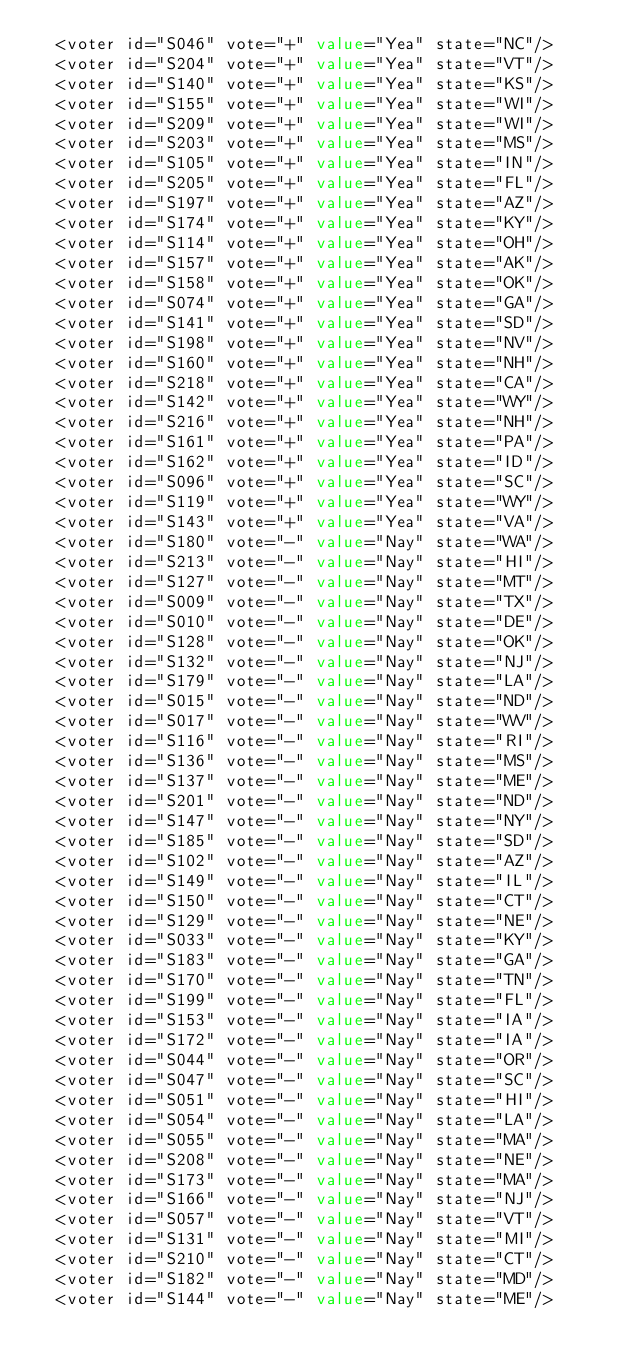<code> <loc_0><loc_0><loc_500><loc_500><_XML_>  <voter id="S046" vote="+" value="Yea" state="NC"/>
  <voter id="S204" vote="+" value="Yea" state="VT"/>
  <voter id="S140" vote="+" value="Yea" state="KS"/>
  <voter id="S155" vote="+" value="Yea" state="WI"/>
  <voter id="S209" vote="+" value="Yea" state="WI"/>
  <voter id="S203" vote="+" value="Yea" state="MS"/>
  <voter id="S105" vote="+" value="Yea" state="IN"/>
  <voter id="S205" vote="+" value="Yea" state="FL"/>
  <voter id="S197" vote="+" value="Yea" state="AZ"/>
  <voter id="S174" vote="+" value="Yea" state="KY"/>
  <voter id="S114" vote="+" value="Yea" state="OH"/>
  <voter id="S157" vote="+" value="Yea" state="AK"/>
  <voter id="S158" vote="+" value="Yea" state="OK"/>
  <voter id="S074" vote="+" value="Yea" state="GA"/>
  <voter id="S141" vote="+" value="Yea" state="SD"/>
  <voter id="S198" vote="+" value="Yea" state="NV"/>
  <voter id="S160" vote="+" value="Yea" state="NH"/>
  <voter id="S218" vote="+" value="Yea" state="CA"/>
  <voter id="S142" vote="+" value="Yea" state="WY"/>
  <voter id="S216" vote="+" value="Yea" state="NH"/>
  <voter id="S161" vote="+" value="Yea" state="PA"/>
  <voter id="S162" vote="+" value="Yea" state="ID"/>
  <voter id="S096" vote="+" value="Yea" state="SC"/>
  <voter id="S119" vote="+" value="Yea" state="WY"/>
  <voter id="S143" vote="+" value="Yea" state="VA"/>
  <voter id="S180" vote="-" value="Nay" state="WA"/>
  <voter id="S213" vote="-" value="Nay" state="HI"/>
  <voter id="S127" vote="-" value="Nay" state="MT"/>
  <voter id="S009" vote="-" value="Nay" state="TX"/>
  <voter id="S010" vote="-" value="Nay" state="DE"/>
  <voter id="S128" vote="-" value="Nay" state="OK"/>
  <voter id="S132" vote="-" value="Nay" state="NJ"/>
  <voter id="S179" vote="-" value="Nay" state="LA"/>
  <voter id="S015" vote="-" value="Nay" state="ND"/>
  <voter id="S017" vote="-" value="Nay" state="WV"/>
  <voter id="S116" vote="-" value="Nay" state="RI"/>
  <voter id="S136" vote="-" value="Nay" state="MS"/>
  <voter id="S137" vote="-" value="Nay" state="ME"/>
  <voter id="S201" vote="-" value="Nay" state="ND"/>
  <voter id="S147" vote="-" value="Nay" state="NY"/>
  <voter id="S185" vote="-" value="Nay" state="SD"/>
  <voter id="S102" vote="-" value="Nay" state="AZ"/>
  <voter id="S149" vote="-" value="Nay" state="IL"/>
  <voter id="S150" vote="-" value="Nay" state="CT"/>
  <voter id="S129" vote="-" value="Nay" state="NE"/>
  <voter id="S033" vote="-" value="Nay" state="KY"/>
  <voter id="S183" vote="-" value="Nay" state="GA"/>
  <voter id="S170" vote="-" value="Nay" state="TN"/>
  <voter id="S199" vote="-" value="Nay" state="FL"/>
  <voter id="S153" vote="-" value="Nay" state="IA"/>
  <voter id="S172" vote="-" value="Nay" state="IA"/>
  <voter id="S044" vote="-" value="Nay" state="OR"/>
  <voter id="S047" vote="-" value="Nay" state="SC"/>
  <voter id="S051" vote="-" value="Nay" state="HI"/>
  <voter id="S054" vote="-" value="Nay" state="LA"/>
  <voter id="S055" vote="-" value="Nay" state="MA"/>
  <voter id="S208" vote="-" value="Nay" state="NE"/>
  <voter id="S173" vote="-" value="Nay" state="MA"/>
  <voter id="S166" vote="-" value="Nay" state="NJ"/>
  <voter id="S057" vote="-" value="Nay" state="VT"/>
  <voter id="S131" vote="-" value="Nay" state="MI"/>
  <voter id="S210" vote="-" value="Nay" state="CT"/>
  <voter id="S182" vote="-" value="Nay" state="MD"/>
  <voter id="S144" vote="-" value="Nay" state="ME"/></code> 